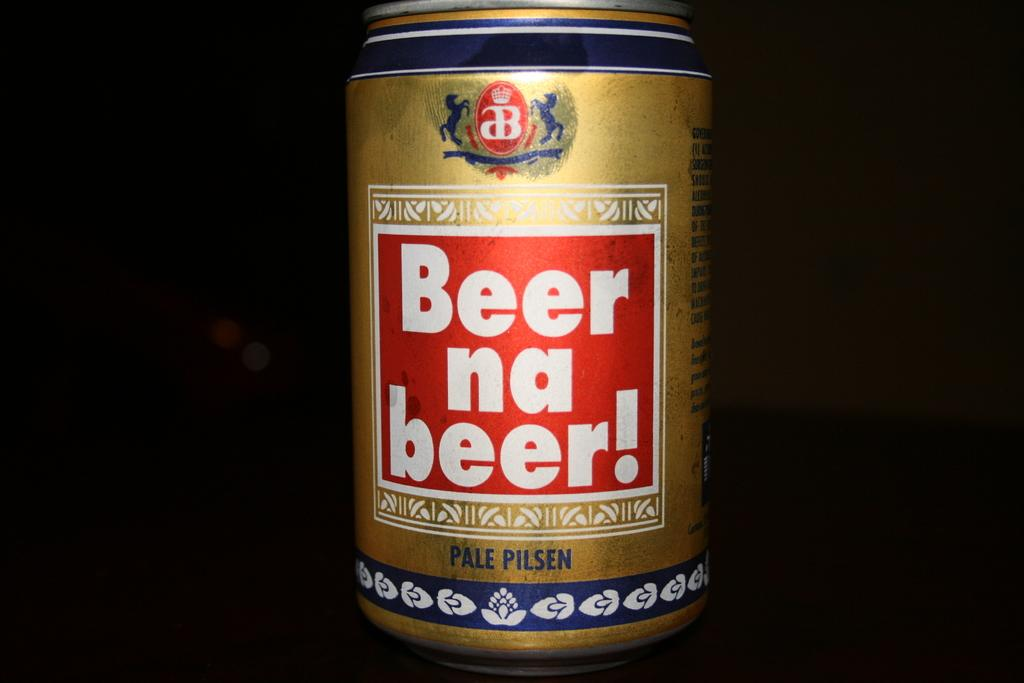Provide a one-sentence caption for the provided image. A gold beer can is show against a black background. 